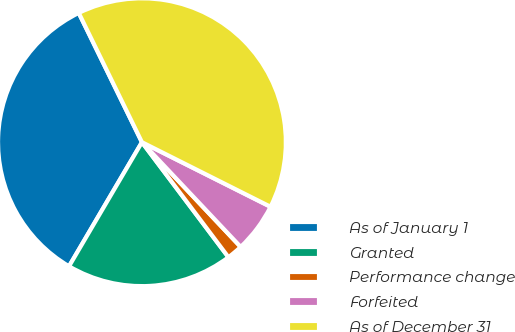<chart> <loc_0><loc_0><loc_500><loc_500><pie_chart><fcel>As of January 1<fcel>Granted<fcel>Performance change<fcel>Forfeited<fcel>As of December 31<nl><fcel>34.31%<fcel>18.72%<fcel>1.77%<fcel>5.56%<fcel>39.64%<nl></chart> 